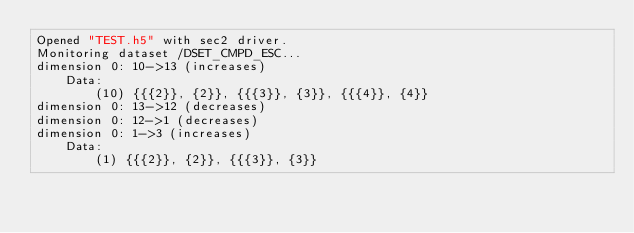Convert code to text. <code><loc_0><loc_0><loc_500><loc_500><_SQL_>Opened "TEST.h5" with sec2 driver.
Monitoring dataset /DSET_CMPD_ESC...
dimension 0: 10->13 (increases)
    Data:
        (10) {{{2}}, {2}}, {{{3}}, {3}}, {{{4}}, {4}}
dimension 0: 13->12 (decreases)
dimension 0: 12->1 (decreases)
dimension 0: 1->3 (increases)
    Data:
        (1) {{{2}}, {2}}, {{{3}}, {3}}
</code> 